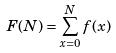Convert formula to latex. <formula><loc_0><loc_0><loc_500><loc_500>F ( N ) = \sum _ { x = 0 } ^ { N } f ( x )</formula> 